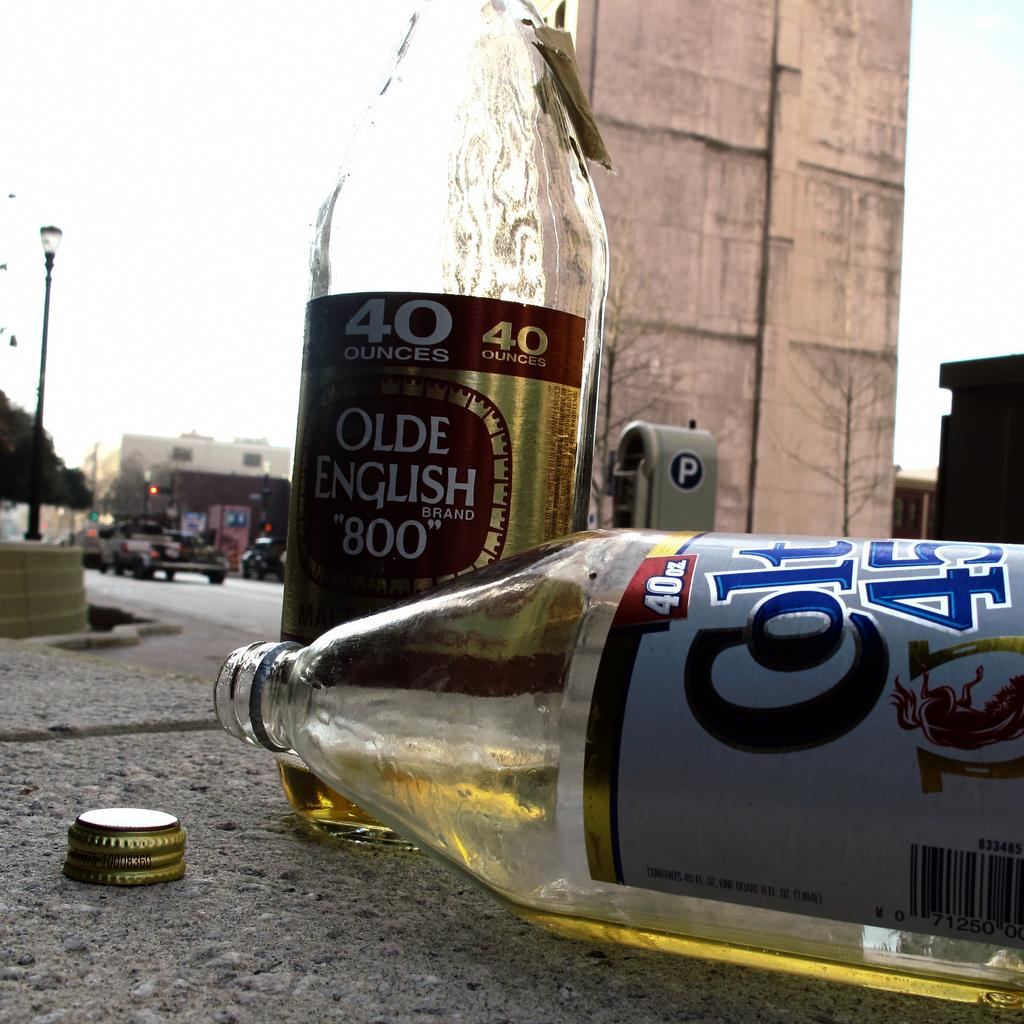<image>
Provide a brief description of the given image. A bottle of Colt 45 laying on it's side, on the sidewalk. 